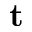<formula> <loc_0><loc_0><loc_500><loc_500>t</formula> 